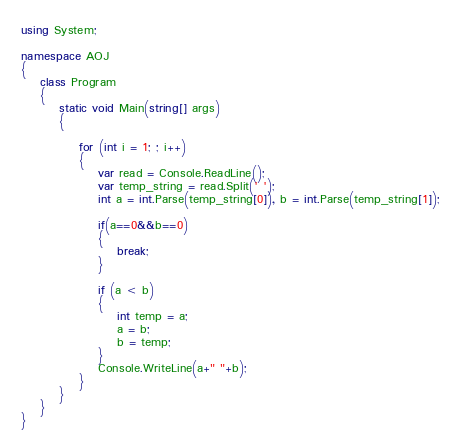Convert code to text. <code><loc_0><loc_0><loc_500><loc_500><_C#_>using System;

namespace AOJ
{
    class Program
    {
        static void Main(string[] args)
        {

            for (int i = 1; ; i++)
            {
                var read = Console.ReadLine();
                var temp_string = read.Split(' ');
                int a = int.Parse(temp_string[0]), b = int.Parse(temp_string[1]);
                
                if(a==0&&b==0)
                {
                    break;
                }

                if (a < b)
                {
                    int temp = a;
                    a = b;
                    b = temp;
                }
                Console.WriteLine(a+" "+b);
            }
        }
    }
}</code> 